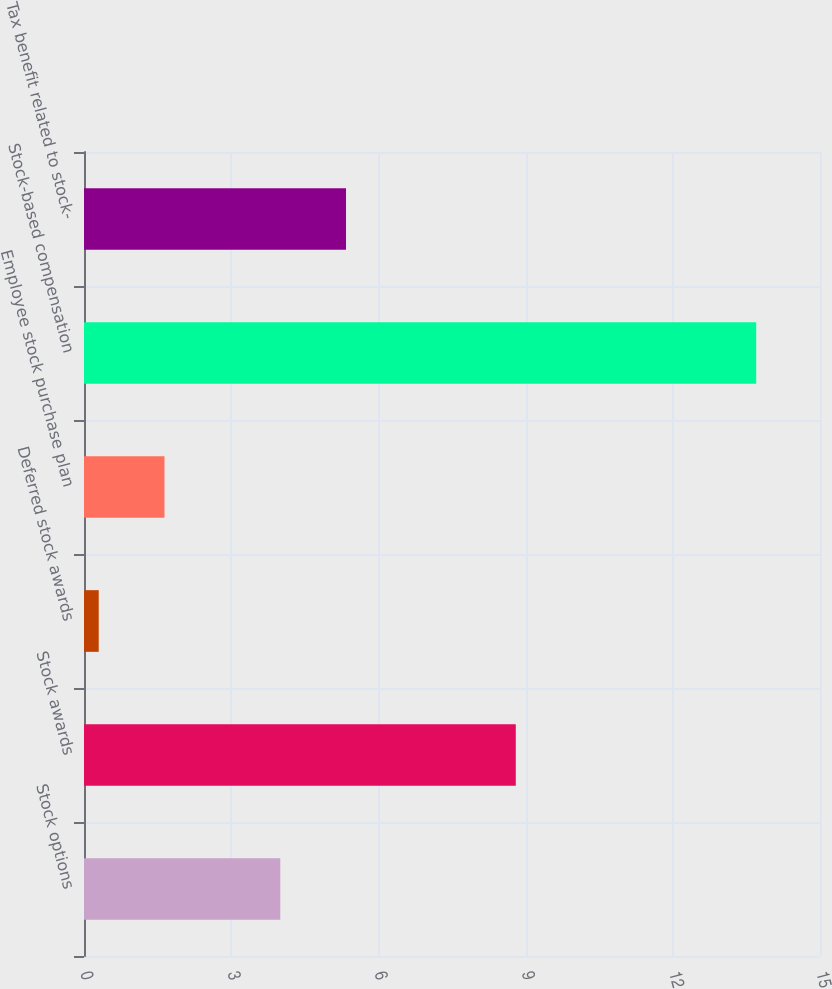<chart> <loc_0><loc_0><loc_500><loc_500><bar_chart><fcel>Stock options<fcel>Stock awards<fcel>Deferred stock awards<fcel>Employee stock purchase plan<fcel>Stock-based compensation<fcel>Tax benefit related to stock-<nl><fcel>4<fcel>8.8<fcel>0.3<fcel>1.64<fcel>13.7<fcel>5.34<nl></chart> 